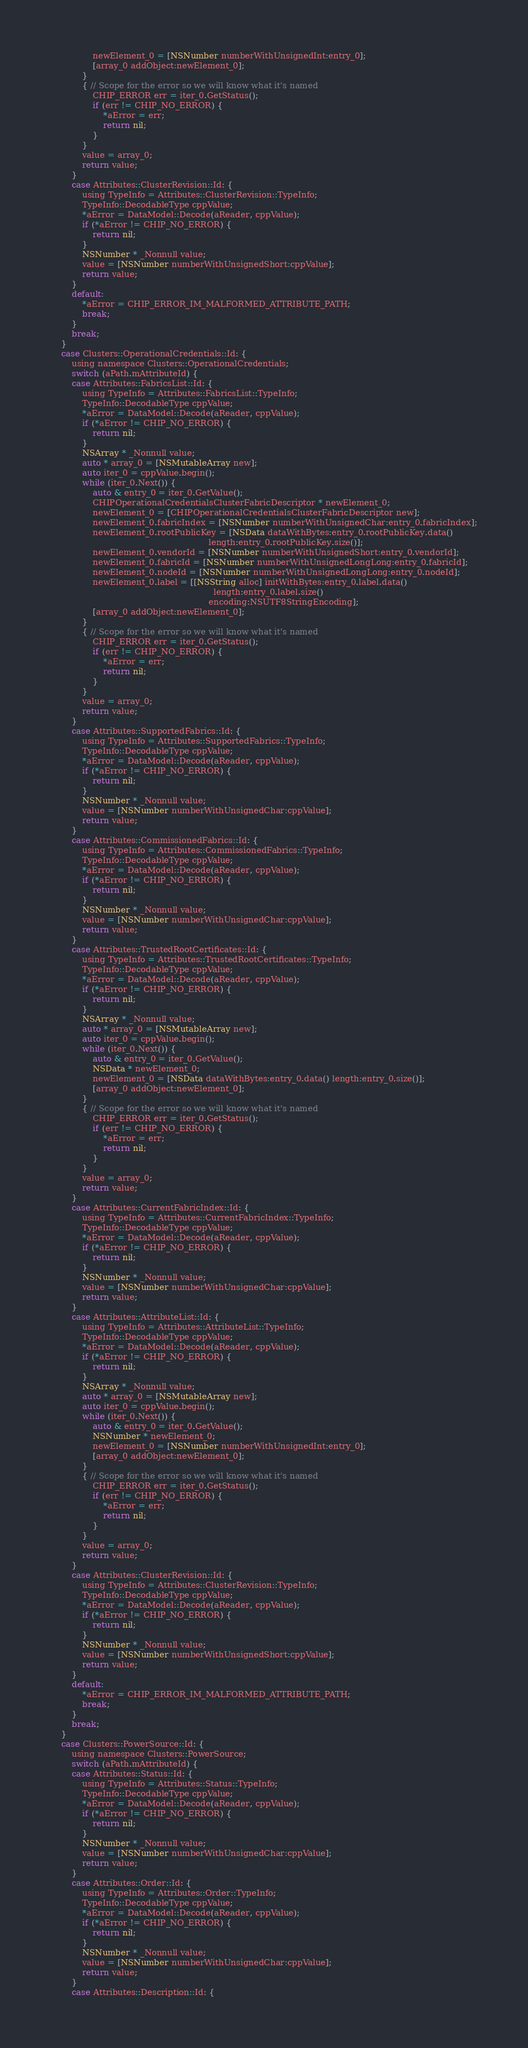<code> <loc_0><loc_0><loc_500><loc_500><_ObjectiveC_>                newElement_0 = [NSNumber numberWithUnsignedInt:entry_0];
                [array_0 addObject:newElement_0];
            }
            { // Scope for the error so we will know what it's named
                CHIP_ERROR err = iter_0.GetStatus();
                if (err != CHIP_NO_ERROR) {
                    *aError = err;
                    return nil;
                }
            }
            value = array_0;
            return value;
        }
        case Attributes::ClusterRevision::Id: {
            using TypeInfo = Attributes::ClusterRevision::TypeInfo;
            TypeInfo::DecodableType cppValue;
            *aError = DataModel::Decode(aReader, cppValue);
            if (*aError != CHIP_NO_ERROR) {
                return nil;
            }
            NSNumber * _Nonnull value;
            value = [NSNumber numberWithUnsignedShort:cppValue];
            return value;
        }
        default:
            *aError = CHIP_ERROR_IM_MALFORMED_ATTRIBUTE_PATH;
            break;
        }
        break;
    }
    case Clusters::OperationalCredentials::Id: {
        using namespace Clusters::OperationalCredentials;
        switch (aPath.mAttributeId) {
        case Attributes::FabricsList::Id: {
            using TypeInfo = Attributes::FabricsList::TypeInfo;
            TypeInfo::DecodableType cppValue;
            *aError = DataModel::Decode(aReader, cppValue);
            if (*aError != CHIP_NO_ERROR) {
                return nil;
            }
            NSArray * _Nonnull value;
            auto * array_0 = [NSMutableArray new];
            auto iter_0 = cppValue.begin();
            while (iter_0.Next()) {
                auto & entry_0 = iter_0.GetValue();
                CHIPOperationalCredentialsClusterFabricDescriptor * newElement_0;
                newElement_0 = [CHIPOperationalCredentialsClusterFabricDescriptor new];
                newElement_0.fabricIndex = [NSNumber numberWithUnsignedChar:entry_0.fabricIndex];
                newElement_0.rootPublicKey = [NSData dataWithBytes:entry_0.rootPublicKey.data()
                                                            length:entry_0.rootPublicKey.size()];
                newElement_0.vendorId = [NSNumber numberWithUnsignedShort:entry_0.vendorId];
                newElement_0.fabricId = [NSNumber numberWithUnsignedLongLong:entry_0.fabricId];
                newElement_0.nodeId = [NSNumber numberWithUnsignedLongLong:entry_0.nodeId];
                newElement_0.label = [[NSString alloc] initWithBytes:entry_0.label.data()
                                                              length:entry_0.label.size()
                                                            encoding:NSUTF8StringEncoding];
                [array_0 addObject:newElement_0];
            }
            { // Scope for the error so we will know what it's named
                CHIP_ERROR err = iter_0.GetStatus();
                if (err != CHIP_NO_ERROR) {
                    *aError = err;
                    return nil;
                }
            }
            value = array_0;
            return value;
        }
        case Attributes::SupportedFabrics::Id: {
            using TypeInfo = Attributes::SupportedFabrics::TypeInfo;
            TypeInfo::DecodableType cppValue;
            *aError = DataModel::Decode(aReader, cppValue);
            if (*aError != CHIP_NO_ERROR) {
                return nil;
            }
            NSNumber * _Nonnull value;
            value = [NSNumber numberWithUnsignedChar:cppValue];
            return value;
        }
        case Attributes::CommissionedFabrics::Id: {
            using TypeInfo = Attributes::CommissionedFabrics::TypeInfo;
            TypeInfo::DecodableType cppValue;
            *aError = DataModel::Decode(aReader, cppValue);
            if (*aError != CHIP_NO_ERROR) {
                return nil;
            }
            NSNumber * _Nonnull value;
            value = [NSNumber numberWithUnsignedChar:cppValue];
            return value;
        }
        case Attributes::TrustedRootCertificates::Id: {
            using TypeInfo = Attributes::TrustedRootCertificates::TypeInfo;
            TypeInfo::DecodableType cppValue;
            *aError = DataModel::Decode(aReader, cppValue);
            if (*aError != CHIP_NO_ERROR) {
                return nil;
            }
            NSArray * _Nonnull value;
            auto * array_0 = [NSMutableArray new];
            auto iter_0 = cppValue.begin();
            while (iter_0.Next()) {
                auto & entry_0 = iter_0.GetValue();
                NSData * newElement_0;
                newElement_0 = [NSData dataWithBytes:entry_0.data() length:entry_0.size()];
                [array_0 addObject:newElement_0];
            }
            { // Scope for the error so we will know what it's named
                CHIP_ERROR err = iter_0.GetStatus();
                if (err != CHIP_NO_ERROR) {
                    *aError = err;
                    return nil;
                }
            }
            value = array_0;
            return value;
        }
        case Attributes::CurrentFabricIndex::Id: {
            using TypeInfo = Attributes::CurrentFabricIndex::TypeInfo;
            TypeInfo::DecodableType cppValue;
            *aError = DataModel::Decode(aReader, cppValue);
            if (*aError != CHIP_NO_ERROR) {
                return nil;
            }
            NSNumber * _Nonnull value;
            value = [NSNumber numberWithUnsignedChar:cppValue];
            return value;
        }
        case Attributes::AttributeList::Id: {
            using TypeInfo = Attributes::AttributeList::TypeInfo;
            TypeInfo::DecodableType cppValue;
            *aError = DataModel::Decode(aReader, cppValue);
            if (*aError != CHIP_NO_ERROR) {
                return nil;
            }
            NSArray * _Nonnull value;
            auto * array_0 = [NSMutableArray new];
            auto iter_0 = cppValue.begin();
            while (iter_0.Next()) {
                auto & entry_0 = iter_0.GetValue();
                NSNumber * newElement_0;
                newElement_0 = [NSNumber numberWithUnsignedInt:entry_0];
                [array_0 addObject:newElement_0];
            }
            { // Scope for the error so we will know what it's named
                CHIP_ERROR err = iter_0.GetStatus();
                if (err != CHIP_NO_ERROR) {
                    *aError = err;
                    return nil;
                }
            }
            value = array_0;
            return value;
        }
        case Attributes::ClusterRevision::Id: {
            using TypeInfo = Attributes::ClusterRevision::TypeInfo;
            TypeInfo::DecodableType cppValue;
            *aError = DataModel::Decode(aReader, cppValue);
            if (*aError != CHIP_NO_ERROR) {
                return nil;
            }
            NSNumber * _Nonnull value;
            value = [NSNumber numberWithUnsignedShort:cppValue];
            return value;
        }
        default:
            *aError = CHIP_ERROR_IM_MALFORMED_ATTRIBUTE_PATH;
            break;
        }
        break;
    }
    case Clusters::PowerSource::Id: {
        using namespace Clusters::PowerSource;
        switch (aPath.mAttributeId) {
        case Attributes::Status::Id: {
            using TypeInfo = Attributes::Status::TypeInfo;
            TypeInfo::DecodableType cppValue;
            *aError = DataModel::Decode(aReader, cppValue);
            if (*aError != CHIP_NO_ERROR) {
                return nil;
            }
            NSNumber * _Nonnull value;
            value = [NSNumber numberWithUnsignedChar:cppValue];
            return value;
        }
        case Attributes::Order::Id: {
            using TypeInfo = Attributes::Order::TypeInfo;
            TypeInfo::DecodableType cppValue;
            *aError = DataModel::Decode(aReader, cppValue);
            if (*aError != CHIP_NO_ERROR) {
                return nil;
            }
            NSNumber * _Nonnull value;
            value = [NSNumber numberWithUnsignedChar:cppValue];
            return value;
        }
        case Attributes::Description::Id: {</code> 